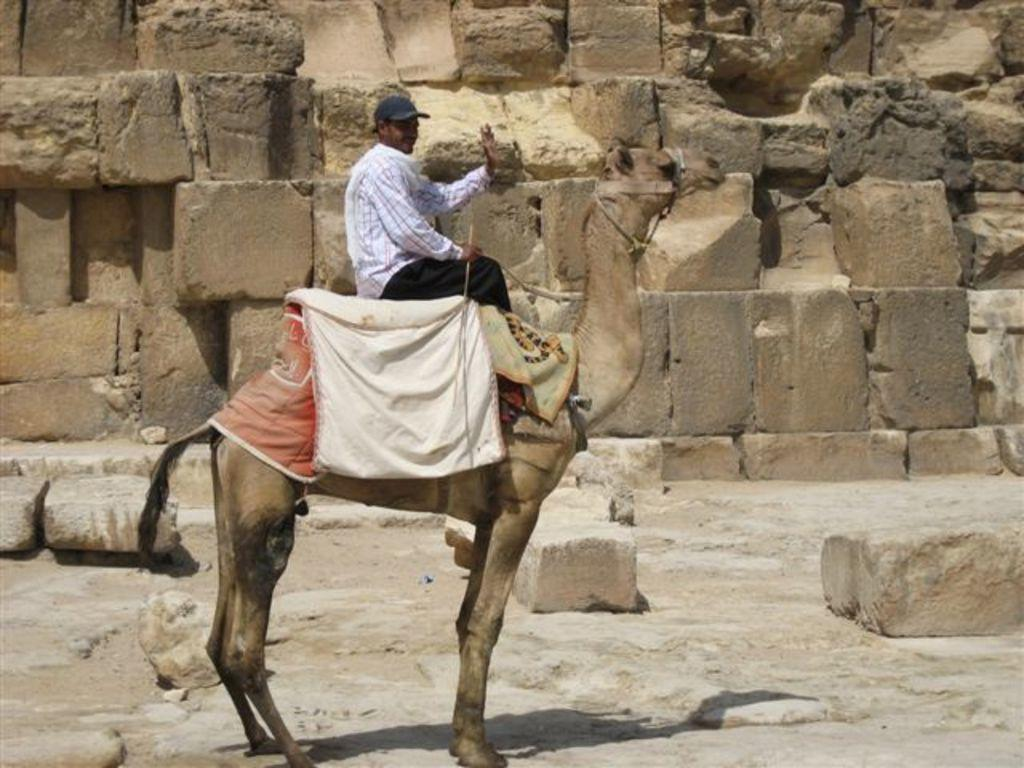What is the main subject in the foreground of the image? There is a person sitting on a camel in the foreground of the image. What can be seen in the background of the image? There are stones and a stone wall in the background of the image. What type of trees can be seen in the image? There are no trees present in the image; it features a person sitting on a camel in the foreground and stones and a stone wall in the background. 